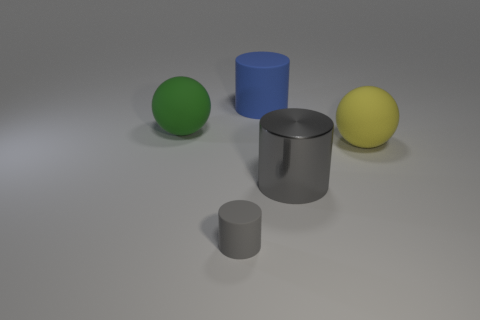How does the lighting in the image affect the appearance of the objects? The lighting in the image appears to be soft and diffused, creating gentle shadows and subtle reflections on the objects. This lighting setup helps to better define the shapes and textures of the objects, enhancing the perceived differences in their materials. 